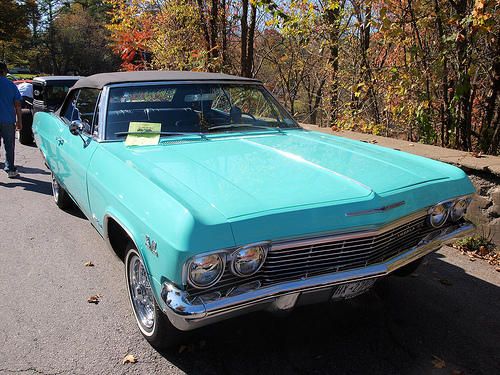<image>
Can you confirm if the flyer is on the wiper blade? No. The flyer is not positioned on the wiper blade. They may be near each other, but the flyer is not supported by or resting on top of the wiper blade. 